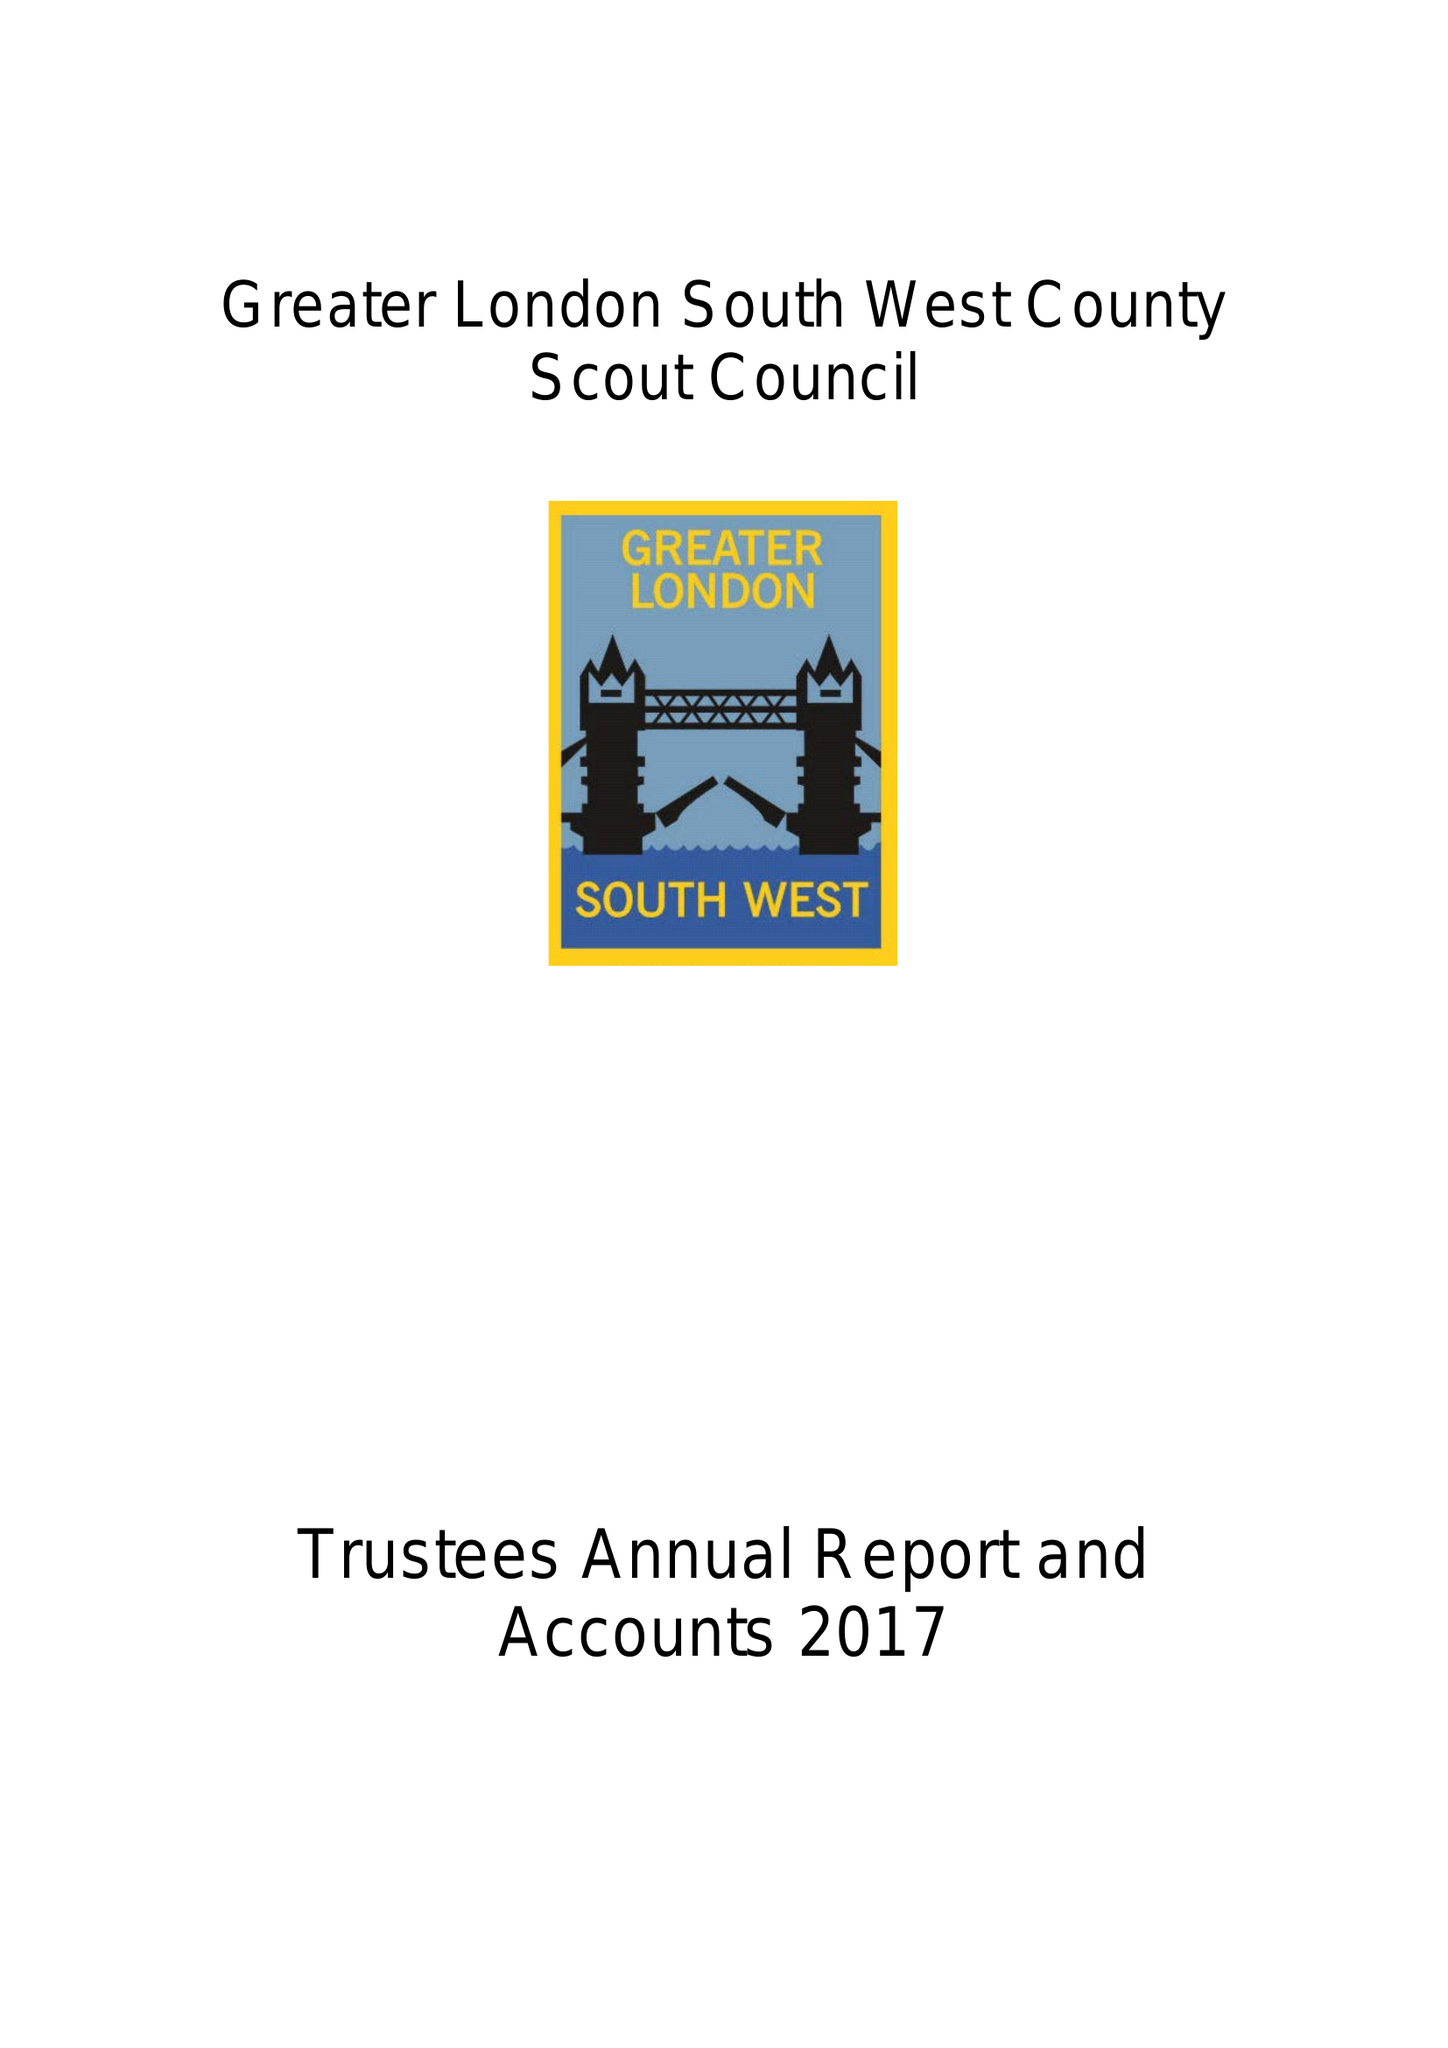What is the value for the address__postcode?
Answer the question using a single word or phrase. KT4 8UD 